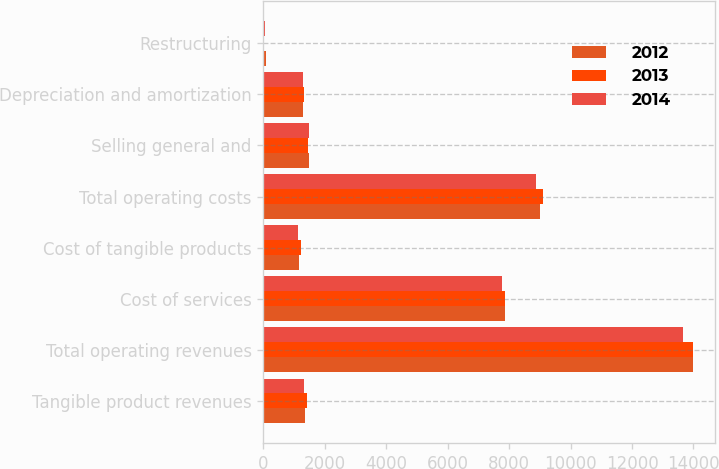Convert chart. <chart><loc_0><loc_0><loc_500><loc_500><stacked_bar_chart><ecel><fcel>Tangible product revenues<fcel>Total operating revenues<fcel>Cost of services<fcel>Cost of tangible products<fcel>Total operating costs<fcel>Selling general and<fcel>Depreciation and amortization<fcel>Restructuring<nl><fcel>2012<fcel>1350<fcel>13996<fcel>7856<fcel>1146<fcel>9002<fcel>1481<fcel>1292<fcel>82<nl><fcel>2013<fcel>1417<fcel>13983<fcel>7880<fcel>1232<fcel>9112<fcel>1468<fcel>1333<fcel>18<nl><fcel>2014<fcel>1322<fcel>13649<fcel>7765<fcel>1114<fcel>8879<fcel>1472<fcel>1297<fcel>67<nl></chart> 